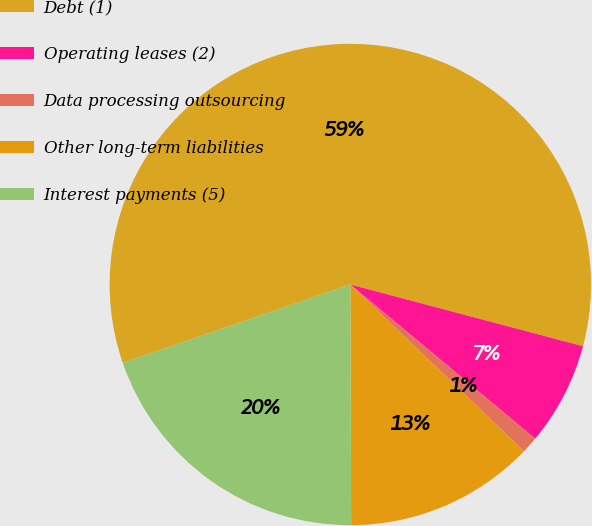<chart> <loc_0><loc_0><loc_500><loc_500><pie_chart><fcel>Debt (1)<fcel>Operating leases (2)<fcel>Data processing outsourcing<fcel>Other long-term liabilities<fcel>Interest payments (5)<nl><fcel>59.4%<fcel>6.94%<fcel>1.11%<fcel>12.77%<fcel>19.78%<nl></chart> 